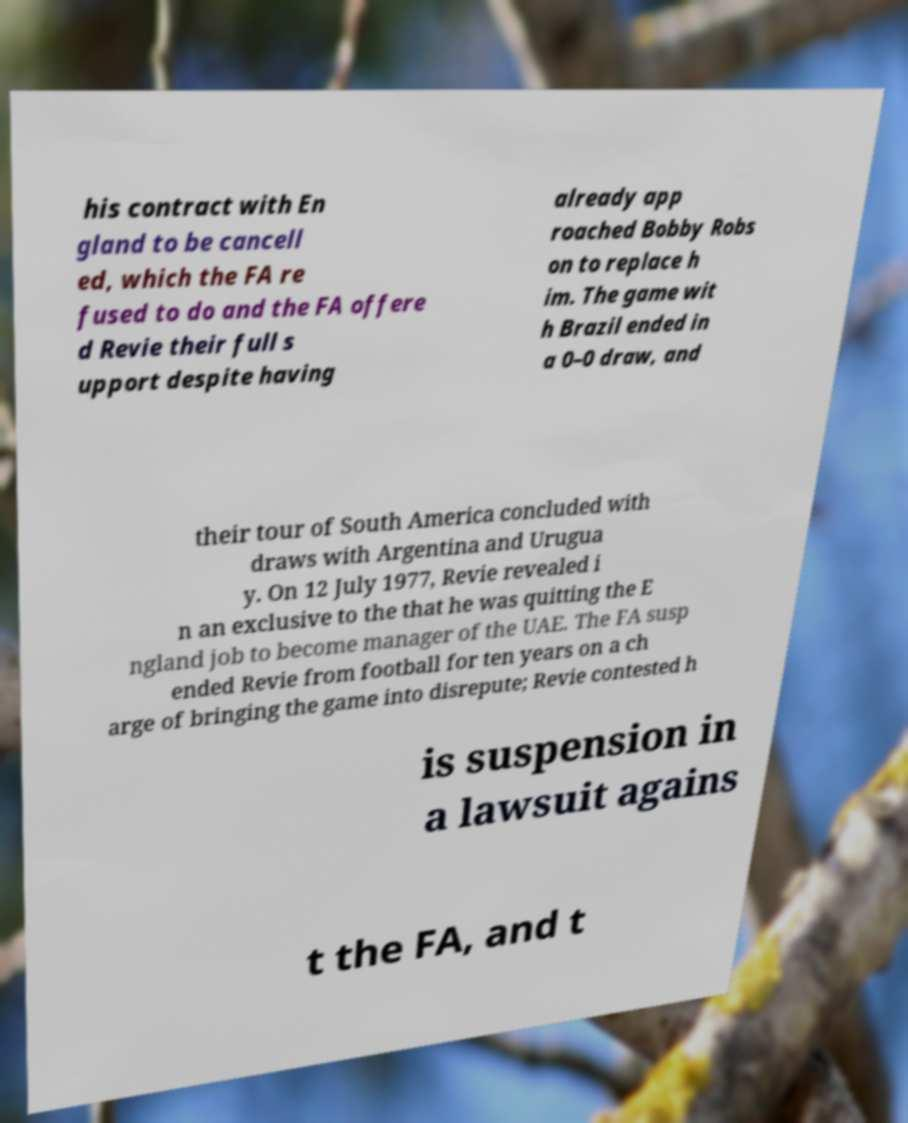Please identify and transcribe the text found in this image. his contract with En gland to be cancell ed, which the FA re fused to do and the FA offere d Revie their full s upport despite having already app roached Bobby Robs on to replace h im. The game wit h Brazil ended in a 0–0 draw, and their tour of South America concluded with draws with Argentina and Urugua y. On 12 July 1977, Revie revealed i n an exclusive to the that he was quitting the E ngland job to become manager of the UAE. The FA susp ended Revie from football for ten years on a ch arge of bringing the game into disrepute; Revie contested h is suspension in a lawsuit agains t the FA, and t 